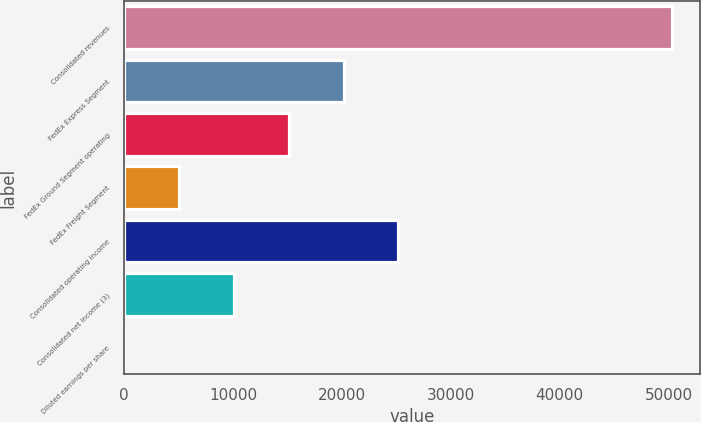Convert chart. <chart><loc_0><loc_0><loc_500><loc_500><bar_chart><fcel>Consolidated revenues<fcel>FedEx Express Segment<fcel>FedEx Ground Segment operating<fcel>FedEx Freight Segment<fcel>Consolidated operating income<fcel>Consolidated net income (3)<fcel>Diluted earnings per share<nl><fcel>50365<fcel>20149.9<fcel>15114.1<fcel>5042.36<fcel>25185.8<fcel>10078.2<fcel>6.51<nl></chart> 